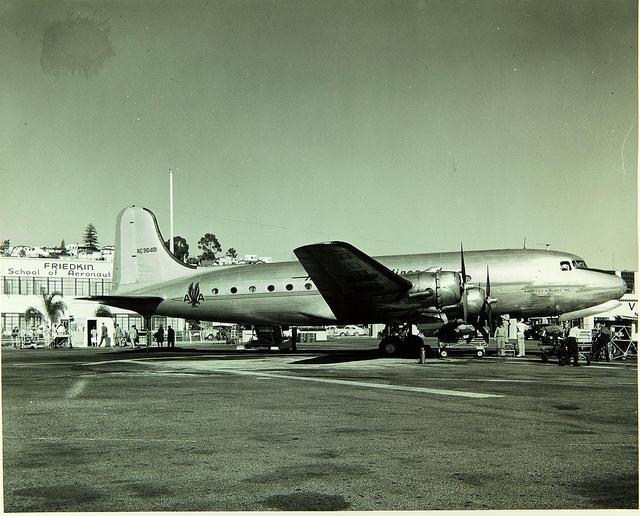What airline is this plane?
Short answer required. American airlines. What type of photo is  this?
Be succinct. Black and white. What airport is this?
Be succinct. Friedkin. 